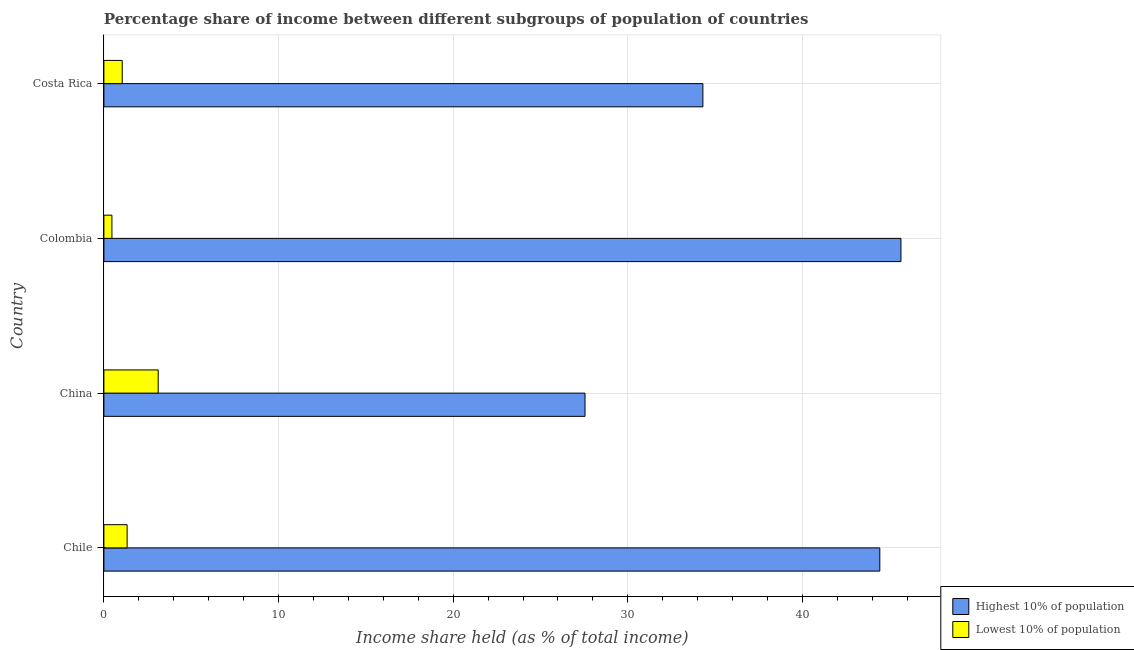How many bars are there on the 2nd tick from the top?
Provide a succinct answer. 2. What is the income share held by highest 10% of the population in Costa Rica?
Your response must be concise. 34.3. Across all countries, what is the maximum income share held by lowest 10% of the population?
Keep it short and to the point. 3.11. Across all countries, what is the minimum income share held by lowest 10% of the population?
Provide a short and direct response. 0.46. In which country was the income share held by highest 10% of the population maximum?
Ensure brevity in your answer.  Colombia. In which country was the income share held by lowest 10% of the population minimum?
Offer a very short reply. Colombia. What is the total income share held by lowest 10% of the population in the graph?
Your answer should be compact. 5.95. What is the difference between the income share held by lowest 10% of the population in Chile and that in Colombia?
Your answer should be very brief. 0.87. What is the difference between the income share held by highest 10% of the population in Costa Rica and the income share held by lowest 10% of the population in China?
Your answer should be compact. 31.19. What is the average income share held by highest 10% of the population per country?
Your answer should be very brief. 37.98. What is the difference between the income share held by lowest 10% of the population and income share held by highest 10% of the population in Costa Rica?
Make the answer very short. -33.25. In how many countries, is the income share held by highest 10% of the population greater than 34 %?
Provide a short and direct response. 3. What is the ratio of the income share held by highest 10% of the population in Chile to that in China?
Your answer should be compact. 1.61. Is the income share held by highest 10% of the population in Chile less than that in Costa Rica?
Make the answer very short. No. Is the difference between the income share held by highest 10% of the population in China and Colombia greater than the difference between the income share held by lowest 10% of the population in China and Colombia?
Ensure brevity in your answer.  No. What is the difference between the highest and the second highest income share held by highest 10% of the population?
Keep it short and to the point. 1.21. What is the difference between the highest and the lowest income share held by lowest 10% of the population?
Offer a terse response. 2.65. In how many countries, is the income share held by highest 10% of the population greater than the average income share held by highest 10% of the population taken over all countries?
Offer a very short reply. 2. What does the 2nd bar from the top in Costa Rica represents?
Give a very brief answer. Highest 10% of population. What does the 2nd bar from the bottom in Chile represents?
Your response must be concise. Lowest 10% of population. How many bars are there?
Offer a terse response. 8. How many countries are there in the graph?
Give a very brief answer. 4. What is the difference between two consecutive major ticks on the X-axis?
Give a very brief answer. 10. Are the values on the major ticks of X-axis written in scientific E-notation?
Your response must be concise. No. Does the graph contain any zero values?
Make the answer very short. No. Where does the legend appear in the graph?
Make the answer very short. Bottom right. How many legend labels are there?
Your answer should be compact. 2. What is the title of the graph?
Give a very brief answer. Percentage share of income between different subgroups of population of countries. What is the label or title of the X-axis?
Offer a very short reply. Income share held (as % of total income). What is the Income share held (as % of total income) in Highest 10% of population in Chile?
Give a very brief answer. 44.43. What is the Income share held (as % of total income) in Lowest 10% of population in Chile?
Offer a terse response. 1.33. What is the Income share held (as % of total income) in Highest 10% of population in China?
Your answer should be very brief. 27.55. What is the Income share held (as % of total income) of Lowest 10% of population in China?
Ensure brevity in your answer.  3.11. What is the Income share held (as % of total income) of Highest 10% of population in Colombia?
Provide a succinct answer. 45.64. What is the Income share held (as % of total income) of Lowest 10% of population in Colombia?
Keep it short and to the point. 0.46. What is the Income share held (as % of total income) of Highest 10% of population in Costa Rica?
Your response must be concise. 34.3. What is the Income share held (as % of total income) in Lowest 10% of population in Costa Rica?
Provide a succinct answer. 1.05. Across all countries, what is the maximum Income share held (as % of total income) of Highest 10% of population?
Give a very brief answer. 45.64. Across all countries, what is the maximum Income share held (as % of total income) in Lowest 10% of population?
Ensure brevity in your answer.  3.11. Across all countries, what is the minimum Income share held (as % of total income) in Highest 10% of population?
Make the answer very short. 27.55. Across all countries, what is the minimum Income share held (as % of total income) of Lowest 10% of population?
Ensure brevity in your answer.  0.46. What is the total Income share held (as % of total income) in Highest 10% of population in the graph?
Provide a succinct answer. 151.92. What is the total Income share held (as % of total income) of Lowest 10% of population in the graph?
Offer a terse response. 5.95. What is the difference between the Income share held (as % of total income) of Highest 10% of population in Chile and that in China?
Ensure brevity in your answer.  16.88. What is the difference between the Income share held (as % of total income) of Lowest 10% of population in Chile and that in China?
Provide a short and direct response. -1.78. What is the difference between the Income share held (as % of total income) of Highest 10% of population in Chile and that in Colombia?
Your answer should be very brief. -1.21. What is the difference between the Income share held (as % of total income) of Lowest 10% of population in Chile and that in Colombia?
Your response must be concise. 0.87. What is the difference between the Income share held (as % of total income) in Highest 10% of population in Chile and that in Costa Rica?
Provide a succinct answer. 10.13. What is the difference between the Income share held (as % of total income) in Lowest 10% of population in Chile and that in Costa Rica?
Ensure brevity in your answer.  0.28. What is the difference between the Income share held (as % of total income) of Highest 10% of population in China and that in Colombia?
Provide a succinct answer. -18.09. What is the difference between the Income share held (as % of total income) in Lowest 10% of population in China and that in Colombia?
Provide a short and direct response. 2.65. What is the difference between the Income share held (as % of total income) in Highest 10% of population in China and that in Costa Rica?
Provide a succinct answer. -6.75. What is the difference between the Income share held (as % of total income) in Lowest 10% of population in China and that in Costa Rica?
Offer a terse response. 2.06. What is the difference between the Income share held (as % of total income) of Highest 10% of population in Colombia and that in Costa Rica?
Provide a succinct answer. 11.34. What is the difference between the Income share held (as % of total income) in Lowest 10% of population in Colombia and that in Costa Rica?
Offer a terse response. -0.59. What is the difference between the Income share held (as % of total income) of Highest 10% of population in Chile and the Income share held (as % of total income) of Lowest 10% of population in China?
Give a very brief answer. 41.32. What is the difference between the Income share held (as % of total income) in Highest 10% of population in Chile and the Income share held (as % of total income) in Lowest 10% of population in Colombia?
Ensure brevity in your answer.  43.97. What is the difference between the Income share held (as % of total income) in Highest 10% of population in Chile and the Income share held (as % of total income) in Lowest 10% of population in Costa Rica?
Keep it short and to the point. 43.38. What is the difference between the Income share held (as % of total income) in Highest 10% of population in China and the Income share held (as % of total income) in Lowest 10% of population in Colombia?
Offer a terse response. 27.09. What is the difference between the Income share held (as % of total income) of Highest 10% of population in Colombia and the Income share held (as % of total income) of Lowest 10% of population in Costa Rica?
Provide a short and direct response. 44.59. What is the average Income share held (as % of total income) of Highest 10% of population per country?
Offer a terse response. 37.98. What is the average Income share held (as % of total income) in Lowest 10% of population per country?
Keep it short and to the point. 1.49. What is the difference between the Income share held (as % of total income) in Highest 10% of population and Income share held (as % of total income) in Lowest 10% of population in Chile?
Provide a short and direct response. 43.1. What is the difference between the Income share held (as % of total income) in Highest 10% of population and Income share held (as % of total income) in Lowest 10% of population in China?
Your answer should be compact. 24.44. What is the difference between the Income share held (as % of total income) of Highest 10% of population and Income share held (as % of total income) of Lowest 10% of population in Colombia?
Give a very brief answer. 45.18. What is the difference between the Income share held (as % of total income) of Highest 10% of population and Income share held (as % of total income) of Lowest 10% of population in Costa Rica?
Your answer should be compact. 33.25. What is the ratio of the Income share held (as % of total income) in Highest 10% of population in Chile to that in China?
Ensure brevity in your answer.  1.61. What is the ratio of the Income share held (as % of total income) in Lowest 10% of population in Chile to that in China?
Provide a short and direct response. 0.43. What is the ratio of the Income share held (as % of total income) of Highest 10% of population in Chile to that in Colombia?
Give a very brief answer. 0.97. What is the ratio of the Income share held (as % of total income) in Lowest 10% of population in Chile to that in Colombia?
Keep it short and to the point. 2.89. What is the ratio of the Income share held (as % of total income) of Highest 10% of population in Chile to that in Costa Rica?
Keep it short and to the point. 1.3. What is the ratio of the Income share held (as % of total income) of Lowest 10% of population in Chile to that in Costa Rica?
Keep it short and to the point. 1.27. What is the ratio of the Income share held (as % of total income) of Highest 10% of population in China to that in Colombia?
Give a very brief answer. 0.6. What is the ratio of the Income share held (as % of total income) of Lowest 10% of population in China to that in Colombia?
Provide a succinct answer. 6.76. What is the ratio of the Income share held (as % of total income) in Highest 10% of population in China to that in Costa Rica?
Make the answer very short. 0.8. What is the ratio of the Income share held (as % of total income) of Lowest 10% of population in China to that in Costa Rica?
Provide a short and direct response. 2.96. What is the ratio of the Income share held (as % of total income) in Highest 10% of population in Colombia to that in Costa Rica?
Give a very brief answer. 1.33. What is the ratio of the Income share held (as % of total income) of Lowest 10% of population in Colombia to that in Costa Rica?
Offer a terse response. 0.44. What is the difference between the highest and the second highest Income share held (as % of total income) of Highest 10% of population?
Ensure brevity in your answer.  1.21. What is the difference between the highest and the second highest Income share held (as % of total income) of Lowest 10% of population?
Your response must be concise. 1.78. What is the difference between the highest and the lowest Income share held (as % of total income) in Highest 10% of population?
Offer a very short reply. 18.09. What is the difference between the highest and the lowest Income share held (as % of total income) of Lowest 10% of population?
Keep it short and to the point. 2.65. 